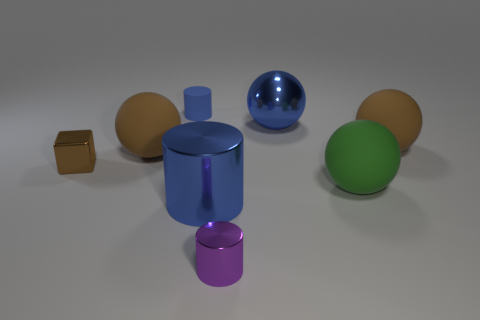Subtract 1 balls. How many balls are left? 3 Add 1 purple things. How many objects exist? 9 Subtract all cylinders. How many objects are left? 5 Add 5 small metal cubes. How many small metal cubes exist? 6 Subtract 0 yellow blocks. How many objects are left? 8 Subtract all gray matte cubes. Subtract all purple things. How many objects are left? 7 Add 1 green matte things. How many green matte things are left? 2 